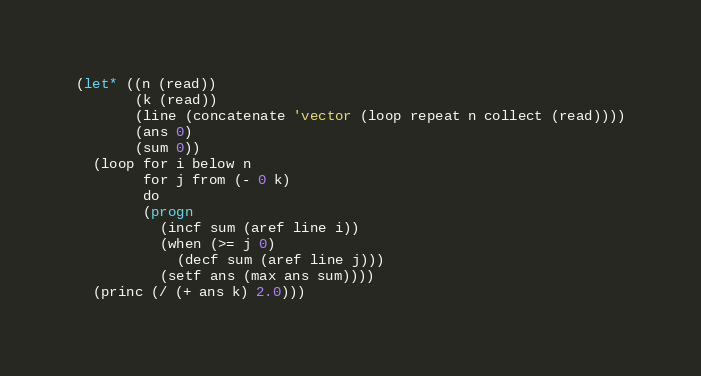Convert code to text. <code><loc_0><loc_0><loc_500><loc_500><_Lisp_>(let* ((n (read))
       (k (read))
       (line (concatenate 'vector (loop repeat n collect (read))))
       (ans 0)
       (sum 0))
  (loop for i below n
        for j from (- 0 k)
        do
        (progn
          (incf sum (aref line i))
          (when (>= j 0)
            (decf sum (aref line j)))
          (setf ans (max ans sum))))
  (princ (/ (+ ans k) 2.0)))
</code> 